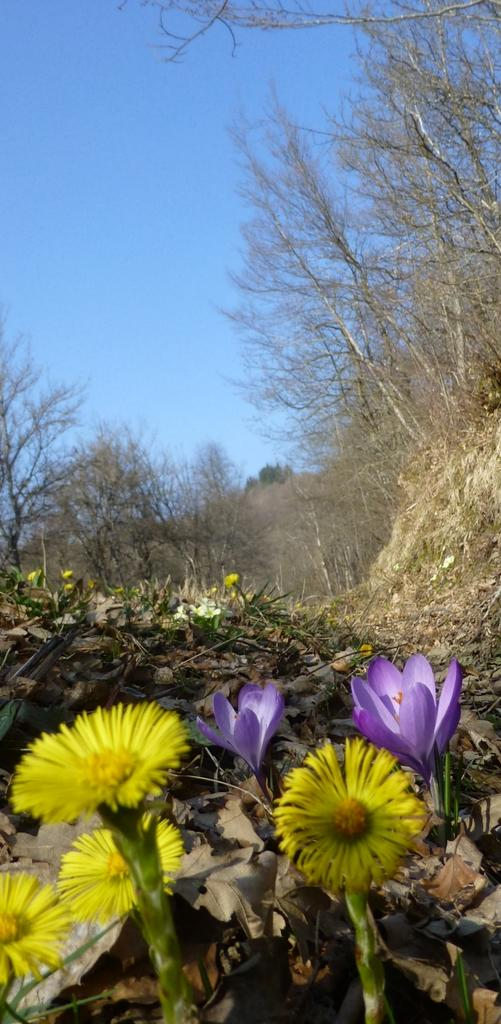What type of plants can be seen in the image? There are flowers in the image. What other plant-related objects can be seen in the image? There are dried leaves in the image. What can be seen in the background of the image? There are trees and the sky visible in the background of the image. How many bears are visible in the image? There are no bears present in the image. What type of clover can be seen growing near the flowers in the image? There is no clover visible in the image; only flowers and dried leaves are present. 